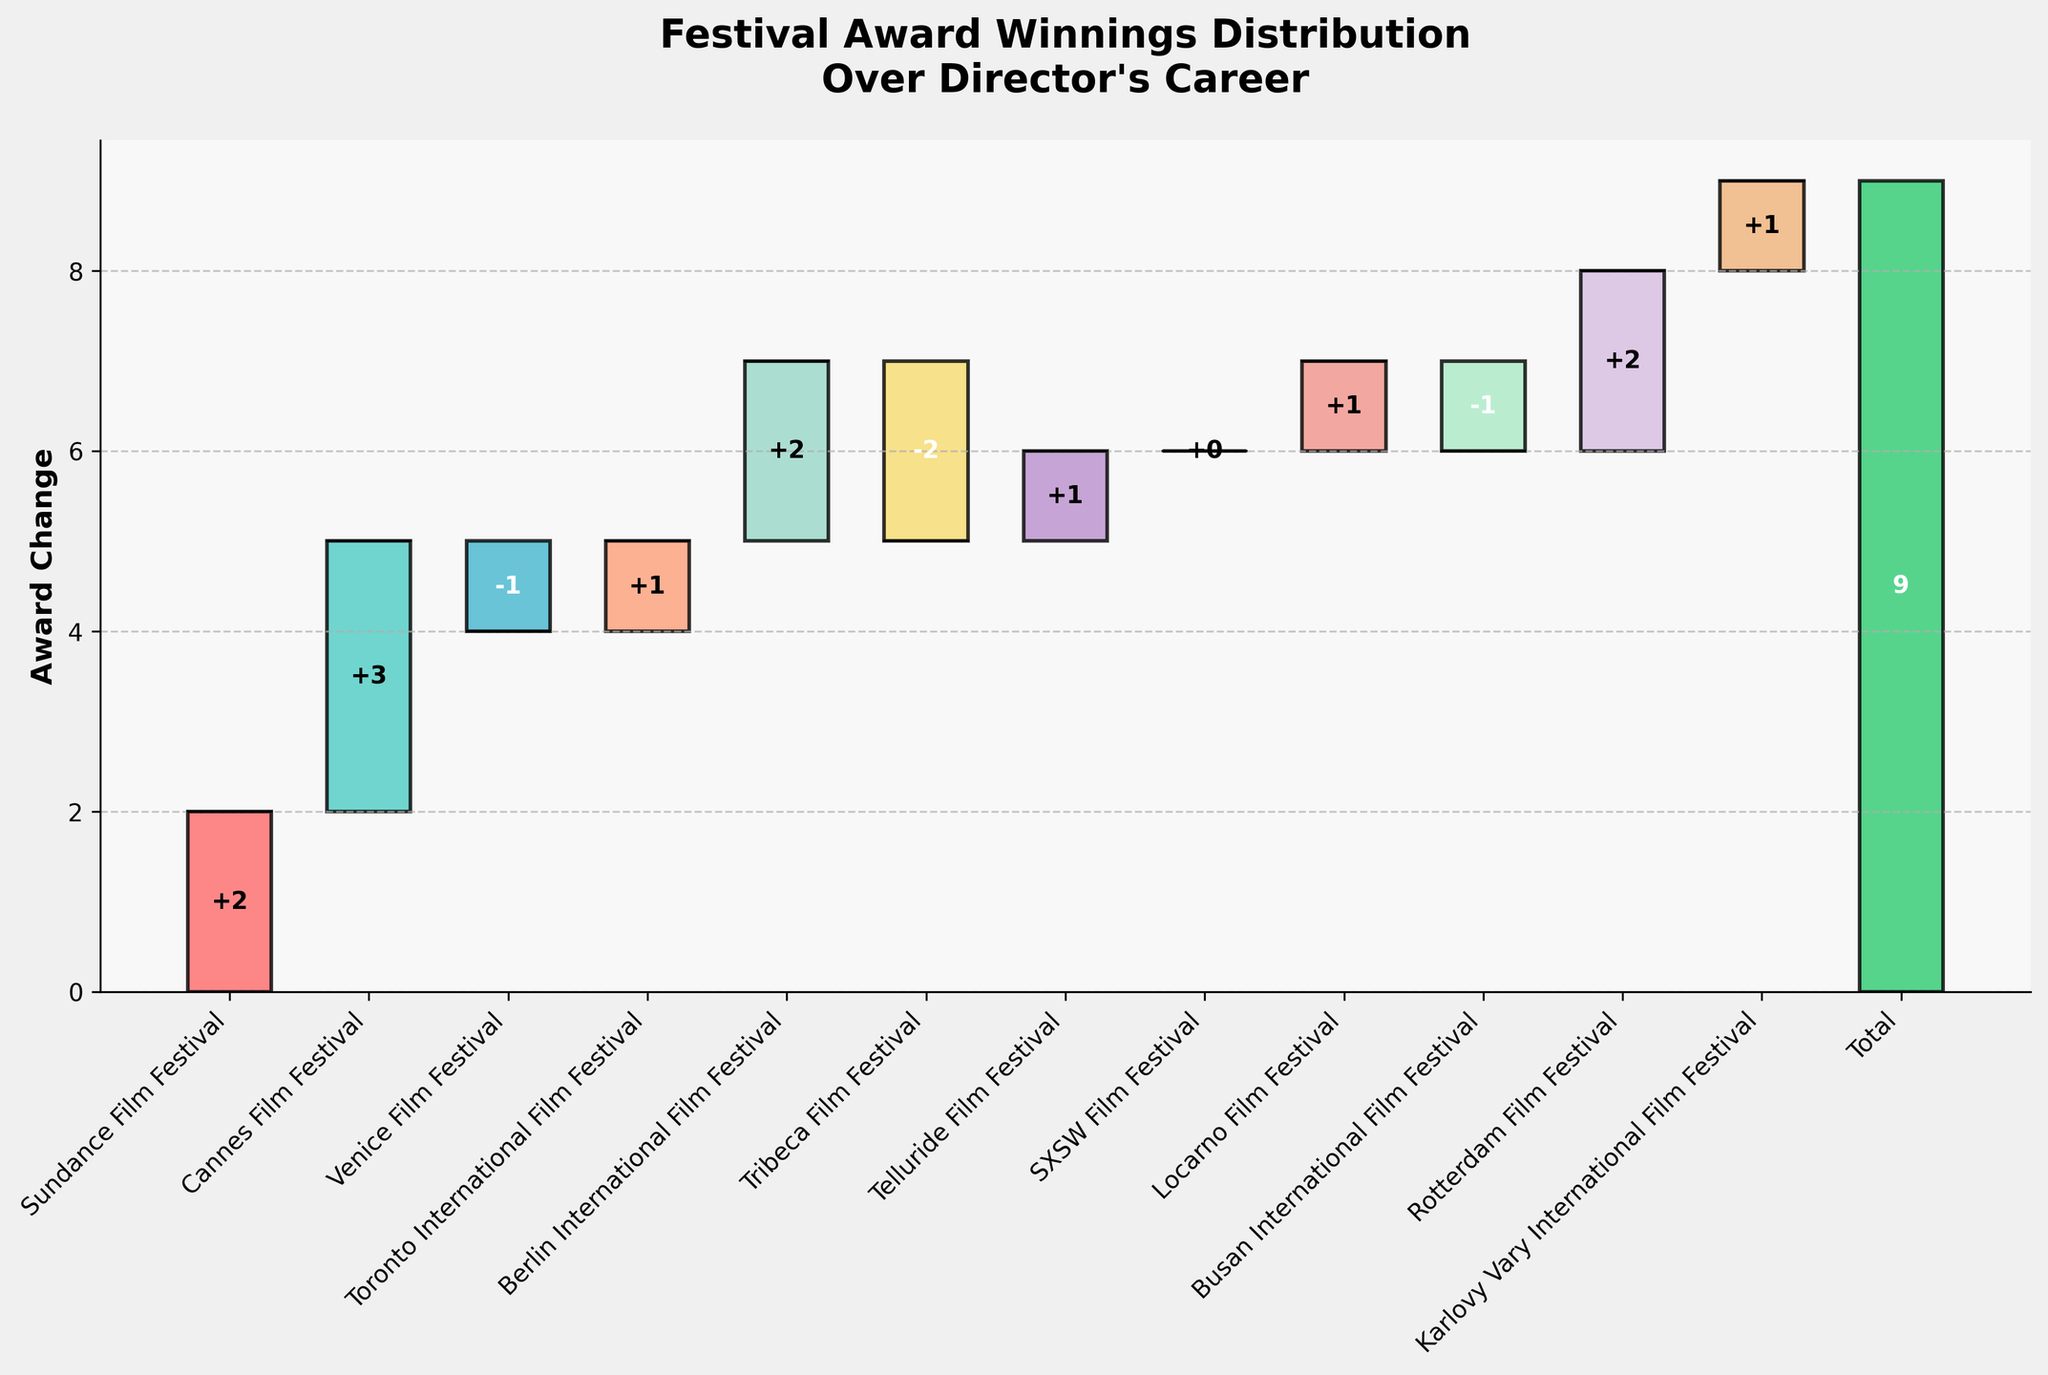What's the title of the Waterfall Chart? The title is the heading text typically placed at the top of the chart. It's meant to provide a summary or the main idea of what the chart is representing.
Answer: "Festival Award Winnings Distribution Over Director's Career" How many festivals showed an increase in award wins? By examining the positive changes in the height of the bars in the chart, we can count the number of festivals with upward changes.
Answer: 8 Which festival saw the largest single increase in award wins? Look for the tallest bar that increases above the base level among all festivals' bars.
Answer: Cannes Film Festival What is the cumulative award change after the Berlin International Film Festival? Sum the changes from Sundance Film Festival to Berlin International Film Festival: 2 + 3 - 1 + 1 + 2 = 7.
Answer: 7 Which festivals had a decrease in award wins? Identify the bars that extend in the negative direction, below the baseline.
Answer: Venice Film Festival, Tribeca Film Festival, Busan International Film Festival What is the difference in award gains between the Toronto International Film Festival and Telluride Film Festival? Subtract the award change for Telluride from the award change for Toronto: 1 - 1.
Answer: 0 How does the award change in the Rotterdam Film Festival compare to Sundance Film Festival? Compare the height of the two bars: Rotterdam (2) and Sundance (2).
Answer: Equal What is the total award change summed from all festivals excluding the total bar? Calculate the sum of the changes from all individual festivals: 2 + 3 - 1 + 1 + 2 - 2 + 1 + 0 + 1 - 1 + 2 + 1 = 9. This confirms why the total bar is marked at 9.
Answer: 9 Which festival has a neutral (zero) change in award wins? Identify the bar that shows no vertical displacement from the baseline.
Answer: SXSW Film Festival 